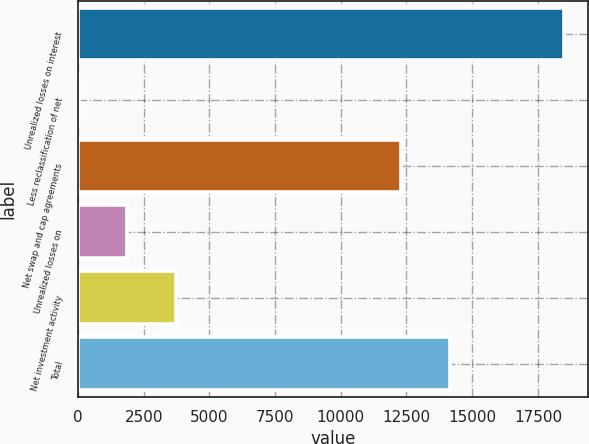<chart> <loc_0><loc_0><loc_500><loc_500><bar_chart><fcel>Unrealized losses on interest<fcel>Less reclassification of net<fcel>Net swap and cap agreements<fcel>Unrealized losses on<fcel>Net investment activity<fcel>Total<nl><fcel>18495<fcel>36<fcel>12305<fcel>1881.9<fcel>3727.8<fcel>14150.9<nl></chart> 